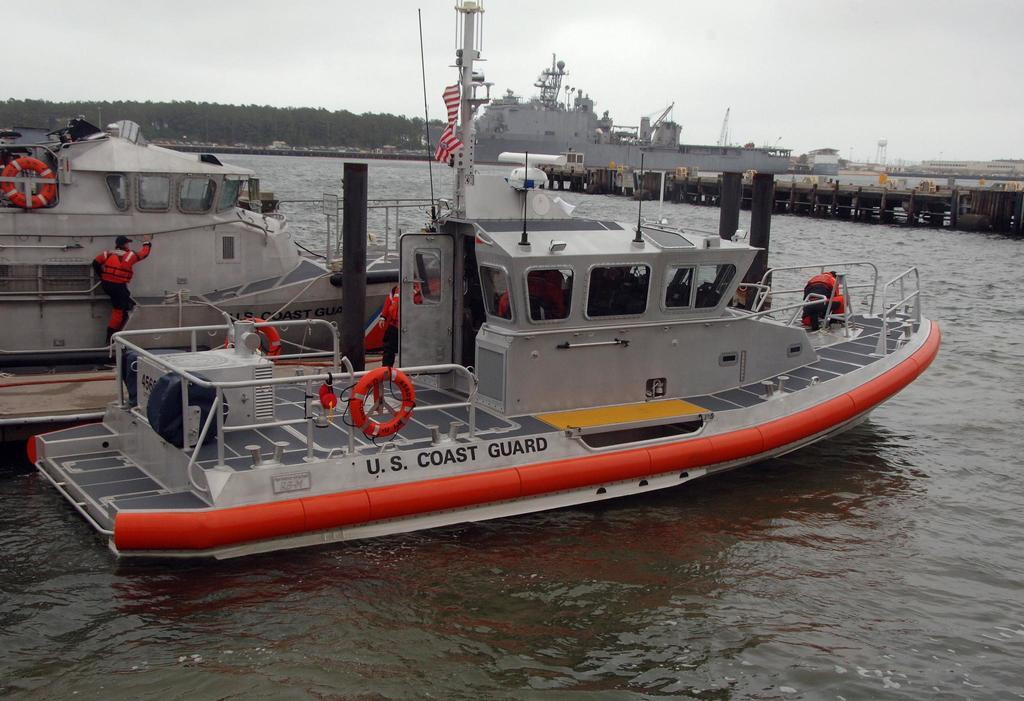What are the people in the image doing? The people in the image are on ships. How are the ships positioned in relation to the water? The ships are above the water. What can be seen in the background of the image? There are trees and the sky visible in the background of the image. What type of pain can be seen on the faces of the people in the image? There is no indication of pain on the faces of the people in the image; they appear to be on ships above the water. What color is the brick used to build the basketball court in the image? There is no brick or basketball court present in the image. 